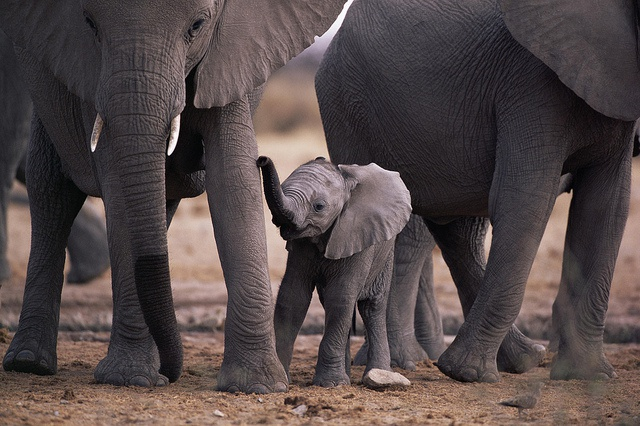Describe the objects in this image and their specific colors. I can see elephant in black and gray tones, elephant in black and gray tones, elephant in black, gray, and darkgray tones, and elephant in black, gray, and darkgray tones in this image. 